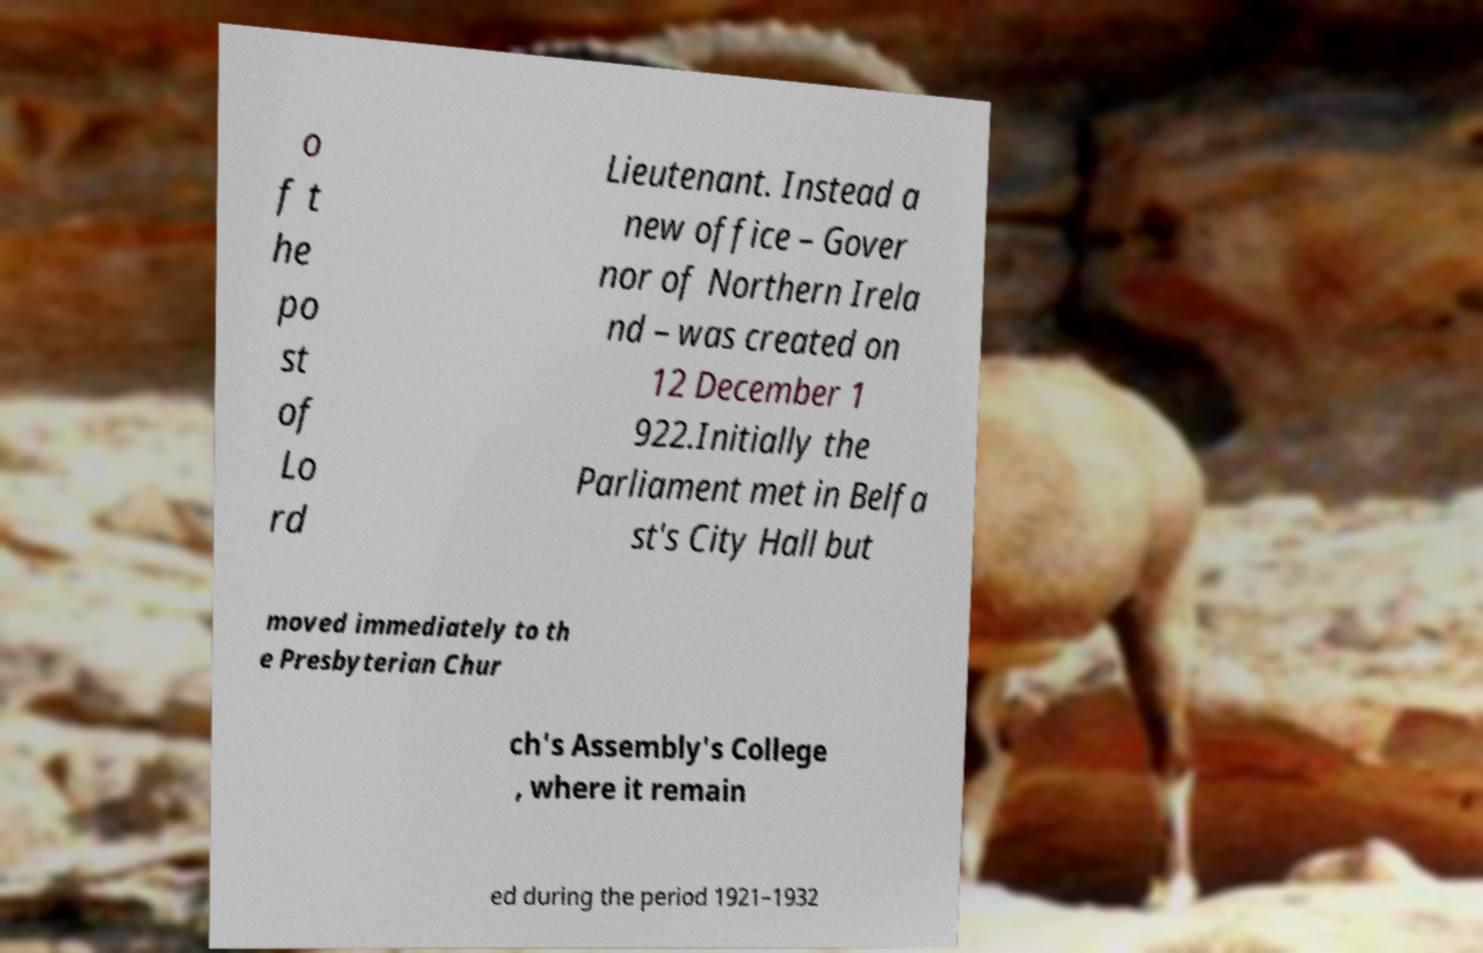For documentation purposes, I need the text within this image transcribed. Could you provide that? o f t he po st of Lo rd Lieutenant. Instead a new office – Gover nor of Northern Irela nd – was created on 12 December 1 922.Initially the Parliament met in Belfa st's City Hall but moved immediately to th e Presbyterian Chur ch's Assembly's College , where it remain ed during the period 1921–1932 